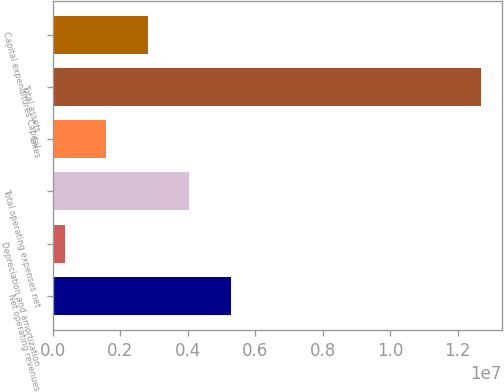<chart> <loc_0><loc_0><loc_500><loc_500><bar_chart><fcel>Net operating revenues<fcel>Depreciation and amortization<fcel>Total operating expenses net<fcel>taxes<fcel>Total assets<fcel>Capital expenditures Capital<nl><fcel>5.28212e+06<fcel>349629<fcel>4.049e+06<fcel>1.58275e+06<fcel>1.26809e+07<fcel>2.81587e+06<nl></chart> 